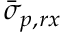<formula> <loc_0><loc_0><loc_500><loc_500>\bar { \sigma } _ { p , r x }</formula> 